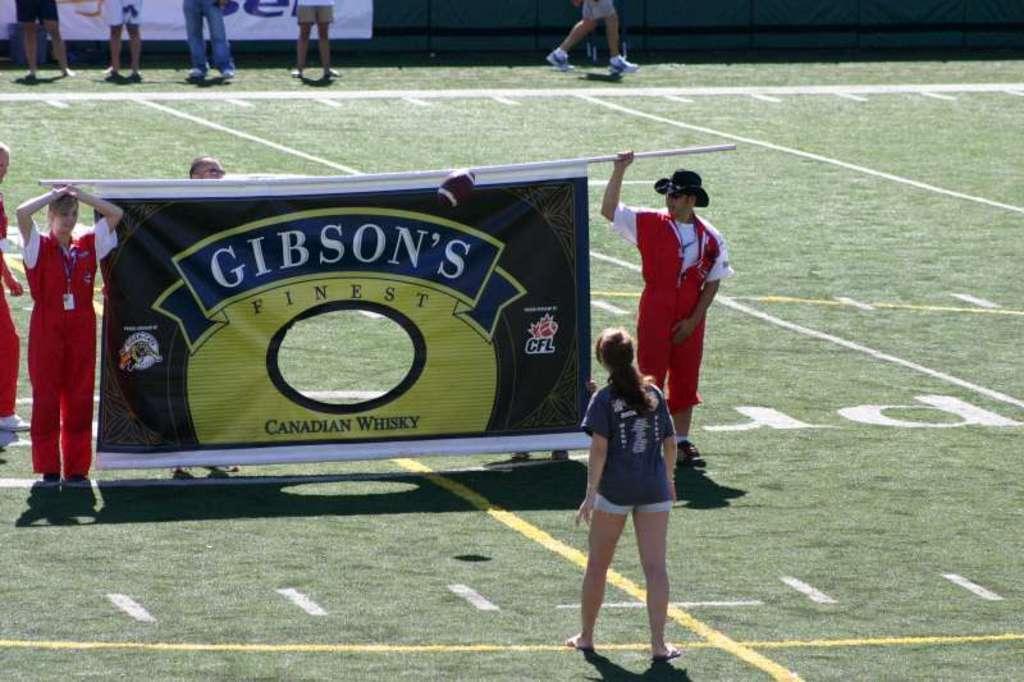Please provide a concise description of this image. In this image we can see persons holding banner on the ground. In the background we can see persons, grass, advertisements and fencing. 